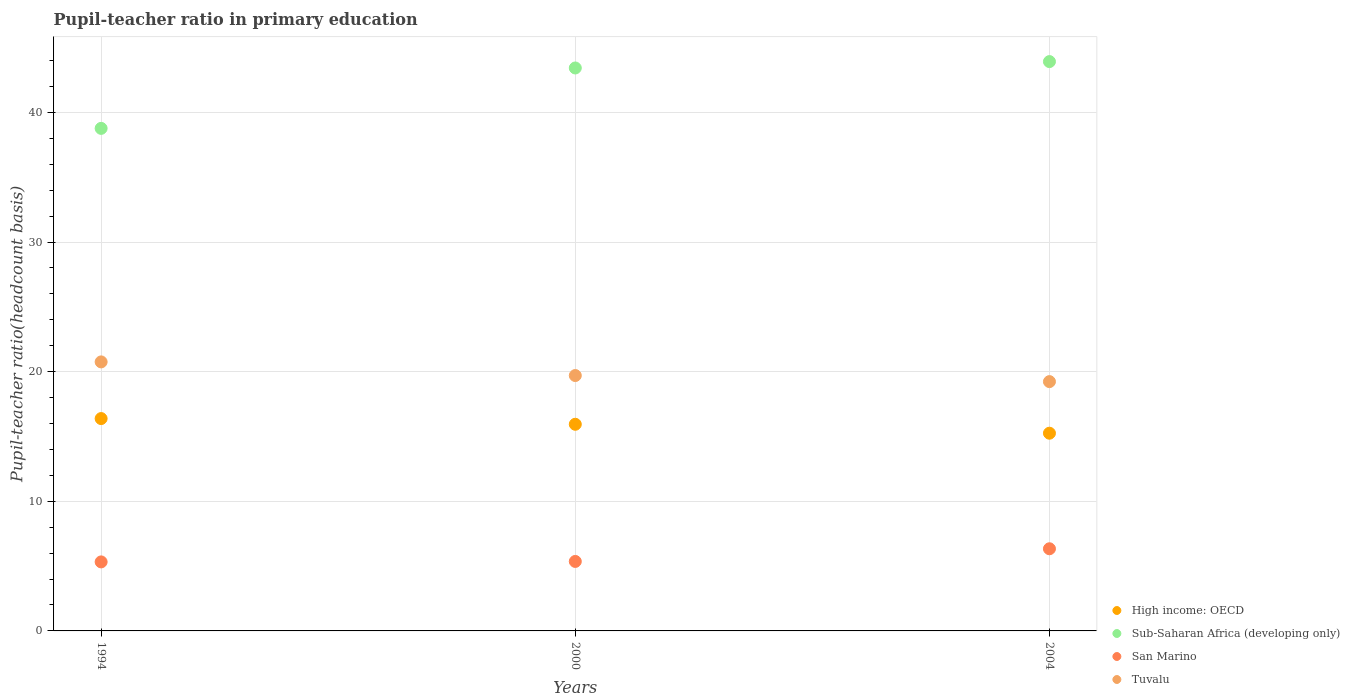Is the number of dotlines equal to the number of legend labels?
Offer a terse response. Yes. What is the pupil-teacher ratio in primary education in Tuvalu in 1994?
Provide a short and direct response. 20.75. Across all years, what is the maximum pupil-teacher ratio in primary education in San Marino?
Make the answer very short. 6.34. Across all years, what is the minimum pupil-teacher ratio in primary education in San Marino?
Make the answer very short. 5.32. In which year was the pupil-teacher ratio in primary education in High income: OECD maximum?
Your answer should be compact. 1994. In which year was the pupil-teacher ratio in primary education in Sub-Saharan Africa (developing only) minimum?
Keep it short and to the point. 1994. What is the total pupil-teacher ratio in primary education in Sub-Saharan Africa (developing only) in the graph?
Your answer should be compact. 126.12. What is the difference between the pupil-teacher ratio in primary education in San Marino in 1994 and that in 2000?
Keep it short and to the point. -0.04. What is the difference between the pupil-teacher ratio in primary education in Sub-Saharan Africa (developing only) in 1994 and the pupil-teacher ratio in primary education in High income: OECD in 2000?
Ensure brevity in your answer.  22.83. What is the average pupil-teacher ratio in primary education in High income: OECD per year?
Give a very brief answer. 15.86. In the year 2004, what is the difference between the pupil-teacher ratio in primary education in San Marino and pupil-teacher ratio in primary education in Sub-Saharan Africa (developing only)?
Make the answer very short. -37.58. What is the ratio of the pupil-teacher ratio in primary education in Sub-Saharan Africa (developing only) in 1994 to that in 2000?
Your answer should be compact. 0.89. Is the pupil-teacher ratio in primary education in Sub-Saharan Africa (developing only) in 1994 less than that in 2004?
Offer a terse response. Yes. What is the difference between the highest and the second highest pupil-teacher ratio in primary education in High income: OECD?
Your response must be concise. 0.44. What is the difference between the highest and the lowest pupil-teacher ratio in primary education in High income: OECD?
Give a very brief answer. 1.13. Does the pupil-teacher ratio in primary education in Tuvalu monotonically increase over the years?
Your answer should be compact. No. Is the pupil-teacher ratio in primary education in San Marino strictly less than the pupil-teacher ratio in primary education in Tuvalu over the years?
Keep it short and to the point. Yes. Does the graph contain any zero values?
Your answer should be very brief. No. Where does the legend appear in the graph?
Offer a terse response. Bottom right. What is the title of the graph?
Make the answer very short. Pupil-teacher ratio in primary education. What is the label or title of the X-axis?
Provide a short and direct response. Years. What is the label or title of the Y-axis?
Your response must be concise. Pupil-teacher ratio(headcount basis). What is the Pupil-teacher ratio(headcount basis) of High income: OECD in 1994?
Give a very brief answer. 16.38. What is the Pupil-teacher ratio(headcount basis) in Sub-Saharan Africa (developing only) in 1994?
Give a very brief answer. 38.77. What is the Pupil-teacher ratio(headcount basis) in San Marino in 1994?
Keep it short and to the point. 5.32. What is the Pupil-teacher ratio(headcount basis) in Tuvalu in 1994?
Give a very brief answer. 20.75. What is the Pupil-teacher ratio(headcount basis) of High income: OECD in 2000?
Provide a short and direct response. 15.94. What is the Pupil-teacher ratio(headcount basis) in Sub-Saharan Africa (developing only) in 2000?
Your answer should be very brief. 43.43. What is the Pupil-teacher ratio(headcount basis) of San Marino in 2000?
Offer a terse response. 5.36. What is the Pupil-teacher ratio(headcount basis) of Tuvalu in 2000?
Offer a very short reply. 19.7. What is the Pupil-teacher ratio(headcount basis) of High income: OECD in 2004?
Provide a succinct answer. 15.25. What is the Pupil-teacher ratio(headcount basis) of Sub-Saharan Africa (developing only) in 2004?
Your answer should be compact. 43.92. What is the Pupil-teacher ratio(headcount basis) of San Marino in 2004?
Offer a very short reply. 6.34. What is the Pupil-teacher ratio(headcount basis) of Tuvalu in 2004?
Your response must be concise. 19.23. Across all years, what is the maximum Pupil-teacher ratio(headcount basis) of High income: OECD?
Your answer should be very brief. 16.38. Across all years, what is the maximum Pupil-teacher ratio(headcount basis) in Sub-Saharan Africa (developing only)?
Your response must be concise. 43.92. Across all years, what is the maximum Pupil-teacher ratio(headcount basis) of San Marino?
Ensure brevity in your answer.  6.34. Across all years, what is the maximum Pupil-teacher ratio(headcount basis) of Tuvalu?
Offer a very short reply. 20.75. Across all years, what is the minimum Pupil-teacher ratio(headcount basis) of High income: OECD?
Ensure brevity in your answer.  15.25. Across all years, what is the minimum Pupil-teacher ratio(headcount basis) of Sub-Saharan Africa (developing only)?
Make the answer very short. 38.77. Across all years, what is the minimum Pupil-teacher ratio(headcount basis) of San Marino?
Provide a short and direct response. 5.32. Across all years, what is the minimum Pupil-teacher ratio(headcount basis) in Tuvalu?
Provide a short and direct response. 19.23. What is the total Pupil-teacher ratio(headcount basis) of High income: OECD in the graph?
Your answer should be very brief. 47.58. What is the total Pupil-teacher ratio(headcount basis) of Sub-Saharan Africa (developing only) in the graph?
Your answer should be compact. 126.12. What is the total Pupil-teacher ratio(headcount basis) in San Marino in the graph?
Your response must be concise. 17.02. What is the total Pupil-teacher ratio(headcount basis) of Tuvalu in the graph?
Provide a succinct answer. 59.69. What is the difference between the Pupil-teacher ratio(headcount basis) of High income: OECD in 1994 and that in 2000?
Give a very brief answer. 0.44. What is the difference between the Pupil-teacher ratio(headcount basis) of Sub-Saharan Africa (developing only) in 1994 and that in 2000?
Make the answer very short. -4.66. What is the difference between the Pupil-teacher ratio(headcount basis) of San Marino in 1994 and that in 2000?
Your answer should be very brief. -0.04. What is the difference between the Pupil-teacher ratio(headcount basis) in Tuvalu in 1994 and that in 2000?
Your response must be concise. 1.05. What is the difference between the Pupil-teacher ratio(headcount basis) in High income: OECD in 1994 and that in 2004?
Your answer should be compact. 1.13. What is the difference between the Pupil-teacher ratio(headcount basis) in Sub-Saharan Africa (developing only) in 1994 and that in 2004?
Your answer should be compact. -5.15. What is the difference between the Pupil-teacher ratio(headcount basis) in San Marino in 1994 and that in 2004?
Offer a terse response. -1.01. What is the difference between the Pupil-teacher ratio(headcount basis) in Tuvalu in 1994 and that in 2004?
Your response must be concise. 1.52. What is the difference between the Pupil-teacher ratio(headcount basis) of High income: OECD in 2000 and that in 2004?
Provide a succinct answer. 0.69. What is the difference between the Pupil-teacher ratio(headcount basis) in Sub-Saharan Africa (developing only) in 2000 and that in 2004?
Make the answer very short. -0.49. What is the difference between the Pupil-teacher ratio(headcount basis) in San Marino in 2000 and that in 2004?
Provide a succinct answer. -0.98. What is the difference between the Pupil-teacher ratio(headcount basis) of Tuvalu in 2000 and that in 2004?
Offer a very short reply. 0.47. What is the difference between the Pupil-teacher ratio(headcount basis) of High income: OECD in 1994 and the Pupil-teacher ratio(headcount basis) of Sub-Saharan Africa (developing only) in 2000?
Your answer should be very brief. -27.05. What is the difference between the Pupil-teacher ratio(headcount basis) of High income: OECD in 1994 and the Pupil-teacher ratio(headcount basis) of San Marino in 2000?
Provide a succinct answer. 11.02. What is the difference between the Pupil-teacher ratio(headcount basis) in High income: OECD in 1994 and the Pupil-teacher ratio(headcount basis) in Tuvalu in 2000?
Provide a short and direct response. -3.32. What is the difference between the Pupil-teacher ratio(headcount basis) in Sub-Saharan Africa (developing only) in 1994 and the Pupil-teacher ratio(headcount basis) in San Marino in 2000?
Make the answer very short. 33.41. What is the difference between the Pupil-teacher ratio(headcount basis) in Sub-Saharan Africa (developing only) in 1994 and the Pupil-teacher ratio(headcount basis) in Tuvalu in 2000?
Offer a terse response. 19.07. What is the difference between the Pupil-teacher ratio(headcount basis) of San Marino in 1994 and the Pupil-teacher ratio(headcount basis) of Tuvalu in 2000?
Offer a terse response. -14.38. What is the difference between the Pupil-teacher ratio(headcount basis) in High income: OECD in 1994 and the Pupil-teacher ratio(headcount basis) in Sub-Saharan Africa (developing only) in 2004?
Keep it short and to the point. -27.54. What is the difference between the Pupil-teacher ratio(headcount basis) in High income: OECD in 1994 and the Pupil-teacher ratio(headcount basis) in San Marino in 2004?
Ensure brevity in your answer.  10.04. What is the difference between the Pupil-teacher ratio(headcount basis) in High income: OECD in 1994 and the Pupil-teacher ratio(headcount basis) in Tuvalu in 2004?
Provide a short and direct response. -2.85. What is the difference between the Pupil-teacher ratio(headcount basis) of Sub-Saharan Africa (developing only) in 1994 and the Pupil-teacher ratio(headcount basis) of San Marino in 2004?
Your answer should be very brief. 32.43. What is the difference between the Pupil-teacher ratio(headcount basis) in Sub-Saharan Africa (developing only) in 1994 and the Pupil-teacher ratio(headcount basis) in Tuvalu in 2004?
Your answer should be very brief. 19.54. What is the difference between the Pupil-teacher ratio(headcount basis) in San Marino in 1994 and the Pupil-teacher ratio(headcount basis) in Tuvalu in 2004?
Offer a very short reply. -13.91. What is the difference between the Pupil-teacher ratio(headcount basis) in High income: OECD in 2000 and the Pupil-teacher ratio(headcount basis) in Sub-Saharan Africa (developing only) in 2004?
Provide a succinct answer. -27.98. What is the difference between the Pupil-teacher ratio(headcount basis) in High income: OECD in 2000 and the Pupil-teacher ratio(headcount basis) in San Marino in 2004?
Offer a terse response. 9.6. What is the difference between the Pupil-teacher ratio(headcount basis) in High income: OECD in 2000 and the Pupil-teacher ratio(headcount basis) in Tuvalu in 2004?
Your response must be concise. -3.29. What is the difference between the Pupil-teacher ratio(headcount basis) in Sub-Saharan Africa (developing only) in 2000 and the Pupil-teacher ratio(headcount basis) in San Marino in 2004?
Keep it short and to the point. 37.09. What is the difference between the Pupil-teacher ratio(headcount basis) of Sub-Saharan Africa (developing only) in 2000 and the Pupil-teacher ratio(headcount basis) of Tuvalu in 2004?
Your answer should be very brief. 24.2. What is the difference between the Pupil-teacher ratio(headcount basis) of San Marino in 2000 and the Pupil-teacher ratio(headcount basis) of Tuvalu in 2004?
Your answer should be compact. -13.87. What is the average Pupil-teacher ratio(headcount basis) of High income: OECD per year?
Give a very brief answer. 15.86. What is the average Pupil-teacher ratio(headcount basis) of Sub-Saharan Africa (developing only) per year?
Make the answer very short. 42.04. What is the average Pupil-teacher ratio(headcount basis) of San Marino per year?
Offer a terse response. 5.67. What is the average Pupil-teacher ratio(headcount basis) in Tuvalu per year?
Provide a short and direct response. 19.9. In the year 1994, what is the difference between the Pupil-teacher ratio(headcount basis) of High income: OECD and Pupil-teacher ratio(headcount basis) of Sub-Saharan Africa (developing only)?
Ensure brevity in your answer.  -22.39. In the year 1994, what is the difference between the Pupil-teacher ratio(headcount basis) of High income: OECD and Pupil-teacher ratio(headcount basis) of San Marino?
Keep it short and to the point. 11.06. In the year 1994, what is the difference between the Pupil-teacher ratio(headcount basis) of High income: OECD and Pupil-teacher ratio(headcount basis) of Tuvalu?
Give a very brief answer. -4.37. In the year 1994, what is the difference between the Pupil-teacher ratio(headcount basis) in Sub-Saharan Africa (developing only) and Pupil-teacher ratio(headcount basis) in San Marino?
Offer a terse response. 33.44. In the year 1994, what is the difference between the Pupil-teacher ratio(headcount basis) in Sub-Saharan Africa (developing only) and Pupil-teacher ratio(headcount basis) in Tuvalu?
Provide a short and direct response. 18.02. In the year 1994, what is the difference between the Pupil-teacher ratio(headcount basis) in San Marino and Pupil-teacher ratio(headcount basis) in Tuvalu?
Provide a short and direct response. -15.43. In the year 2000, what is the difference between the Pupil-teacher ratio(headcount basis) of High income: OECD and Pupil-teacher ratio(headcount basis) of Sub-Saharan Africa (developing only)?
Offer a very short reply. -27.49. In the year 2000, what is the difference between the Pupil-teacher ratio(headcount basis) of High income: OECD and Pupil-teacher ratio(headcount basis) of San Marino?
Your answer should be very brief. 10.58. In the year 2000, what is the difference between the Pupil-teacher ratio(headcount basis) of High income: OECD and Pupil-teacher ratio(headcount basis) of Tuvalu?
Give a very brief answer. -3.76. In the year 2000, what is the difference between the Pupil-teacher ratio(headcount basis) of Sub-Saharan Africa (developing only) and Pupil-teacher ratio(headcount basis) of San Marino?
Provide a short and direct response. 38.07. In the year 2000, what is the difference between the Pupil-teacher ratio(headcount basis) of Sub-Saharan Africa (developing only) and Pupil-teacher ratio(headcount basis) of Tuvalu?
Ensure brevity in your answer.  23.73. In the year 2000, what is the difference between the Pupil-teacher ratio(headcount basis) of San Marino and Pupil-teacher ratio(headcount basis) of Tuvalu?
Your answer should be compact. -14.34. In the year 2004, what is the difference between the Pupil-teacher ratio(headcount basis) of High income: OECD and Pupil-teacher ratio(headcount basis) of Sub-Saharan Africa (developing only)?
Provide a succinct answer. -28.67. In the year 2004, what is the difference between the Pupil-teacher ratio(headcount basis) of High income: OECD and Pupil-teacher ratio(headcount basis) of San Marino?
Keep it short and to the point. 8.91. In the year 2004, what is the difference between the Pupil-teacher ratio(headcount basis) in High income: OECD and Pupil-teacher ratio(headcount basis) in Tuvalu?
Keep it short and to the point. -3.98. In the year 2004, what is the difference between the Pupil-teacher ratio(headcount basis) in Sub-Saharan Africa (developing only) and Pupil-teacher ratio(headcount basis) in San Marino?
Your answer should be compact. 37.58. In the year 2004, what is the difference between the Pupil-teacher ratio(headcount basis) of Sub-Saharan Africa (developing only) and Pupil-teacher ratio(headcount basis) of Tuvalu?
Your answer should be compact. 24.69. In the year 2004, what is the difference between the Pupil-teacher ratio(headcount basis) of San Marino and Pupil-teacher ratio(headcount basis) of Tuvalu?
Your response must be concise. -12.9. What is the ratio of the Pupil-teacher ratio(headcount basis) of High income: OECD in 1994 to that in 2000?
Your answer should be compact. 1.03. What is the ratio of the Pupil-teacher ratio(headcount basis) in Sub-Saharan Africa (developing only) in 1994 to that in 2000?
Give a very brief answer. 0.89. What is the ratio of the Pupil-teacher ratio(headcount basis) of Tuvalu in 1994 to that in 2000?
Keep it short and to the point. 1.05. What is the ratio of the Pupil-teacher ratio(headcount basis) of High income: OECD in 1994 to that in 2004?
Keep it short and to the point. 1.07. What is the ratio of the Pupil-teacher ratio(headcount basis) in Sub-Saharan Africa (developing only) in 1994 to that in 2004?
Offer a very short reply. 0.88. What is the ratio of the Pupil-teacher ratio(headcount basis) in San Marino in 1994 to that in 2004?
Your answer should be very brief. 0.84. What is the ratio of the Pupil-teacher ratio(headcount basis) of Tuvalu in 1994 to that in 2004?
Make the answer very short. 1.08. What is the ratio of the Pupil-teacher ratio(headcount basis) in High income: OECD in 2000 to that in 2004?
Keep it short and to the point. 1.05. What is the ratio of the Pupil-teacher ratio(headcount basis) of San Marino in 2000 to that in 2004?
Give a very brief answer. 0.85. What is the ratio of the Pupil-teacher ratio(headcount basis) of Tuvalu in 2000 to that in 2004?
Make the answer very short. 1.02. What is the difference between the highest and the second highest Pupil-teacher ratio(headcount basis) of High income: OECD?
Provide a succinct answer. 0.44. What is the difference between the highest and the second highest Pupil-teacher ratio(headcount basis) in Sub-Saharan Africa (developing only)?
Keep it short and to the point. 0.49. What is the difference between the highest and the second highest Pupil-teacher ratio(headcount basis) of San Marino?
Offer a very short reply. 0.98. What is the difference between the highest and the second highest Pupil-teacher ratio(headcount basis) in Tuvalu?
Offer a very short reply. 1.05. What is the difference between the highest and the lowest Pupil-teacher ratio(headcount basis) of High income: OECD?
Make the answer very short. 1.13. What is the difference between the highest and the lowest Pupil-teacher ratio(headcount basis) of Sub-Saharan Africa (developing only)?
Give a very brief answer. 5.15. What is the difference between the highest and the lowest Pupil-teacher ratio(headcount basis) of San Marino?
Make the answer very short. 1.01. What is the difference between the highest and the lowest Pupil-teacher ratio(headcount basis) of Tuvalu?
Provide a succinct answer. 1.52. 